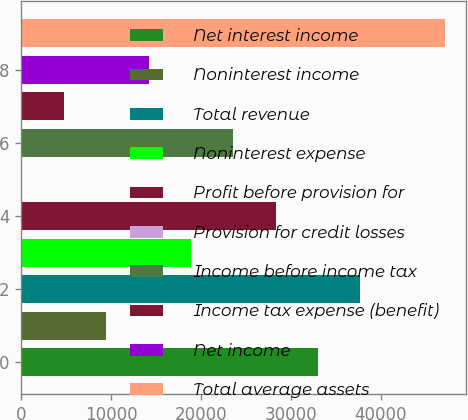<chart> <loc_0><loc_0><loc_500><loc_500><bar_chart><fcel>Net interest income<fcel>Noninterest income<fcel>Total revenue<fcel>Noninterest expense<fcel>Profit before provision for<fcel>Provision for credit losses<fcel>Income before income tax<fcel>Income tax expense (benefit)<fcel>Net income<fcel>Total average assets<nl><fcel>33025.4<fcel>9469.4<fcel>37736.6<fcel>18891.8<fcel>28314.2<fcel>47<fcel>23603<fcel>4758.2<fcel>14180.6<fcel>47159<nl></chart> 